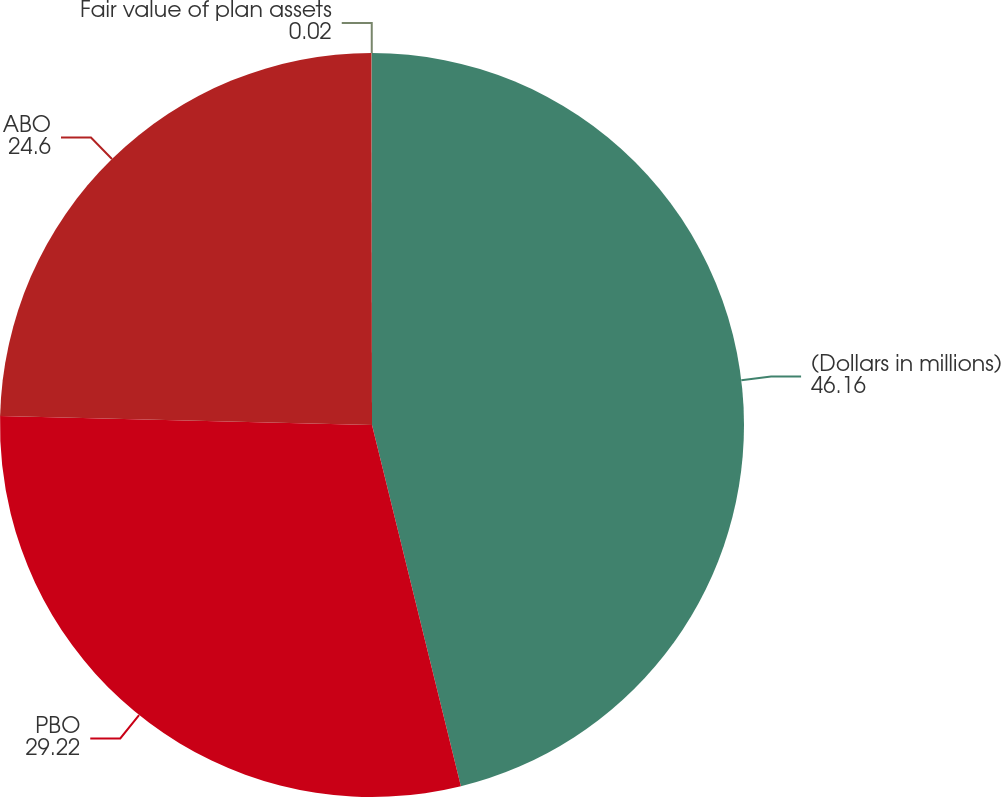<chart> <loc_0><loc_0><loc_500><loc_500><pie_chart><fcel>(Dollars in millions)<fcel>PBO<fcel>ABO<fcel>Fair value of plan assets<nl><fcel>46.16%<fcel>29.22%<fcel>24.6%<fcel>0.02%<nl></chart> 